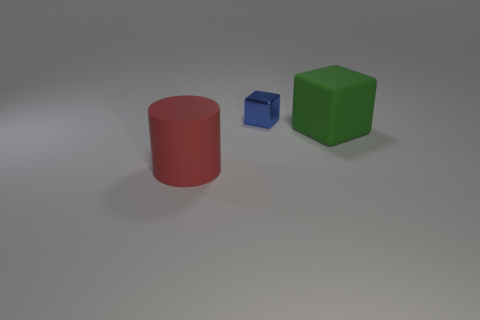Add 3 red cubes. How many objects exist? 6 Subtract all cylinders. How many objects are left? 2 Subtract all green blocks. How many blocks are left? 1 Subtract all purple cylinders. Subtract all red cubes. How many cylinders are left? 1 Subtract all large cyan rubber spheres. Subtract all tiny blue things. How many objects are left? 2 Add 3 matte things. How many matte things are left? 5 Add 2 tiny shiny blocks. How many tiny shiny blocks exist? 3 Subtract 1 blue blocks. How many objects are left? 2 